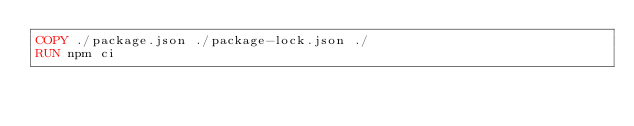Convert code to text. <code><loc_0><loc_0><loc_500><loc_500><_Dockerfile_>COPY ./package.json ./package-lock.json ./
RUN npm ci
</code> 